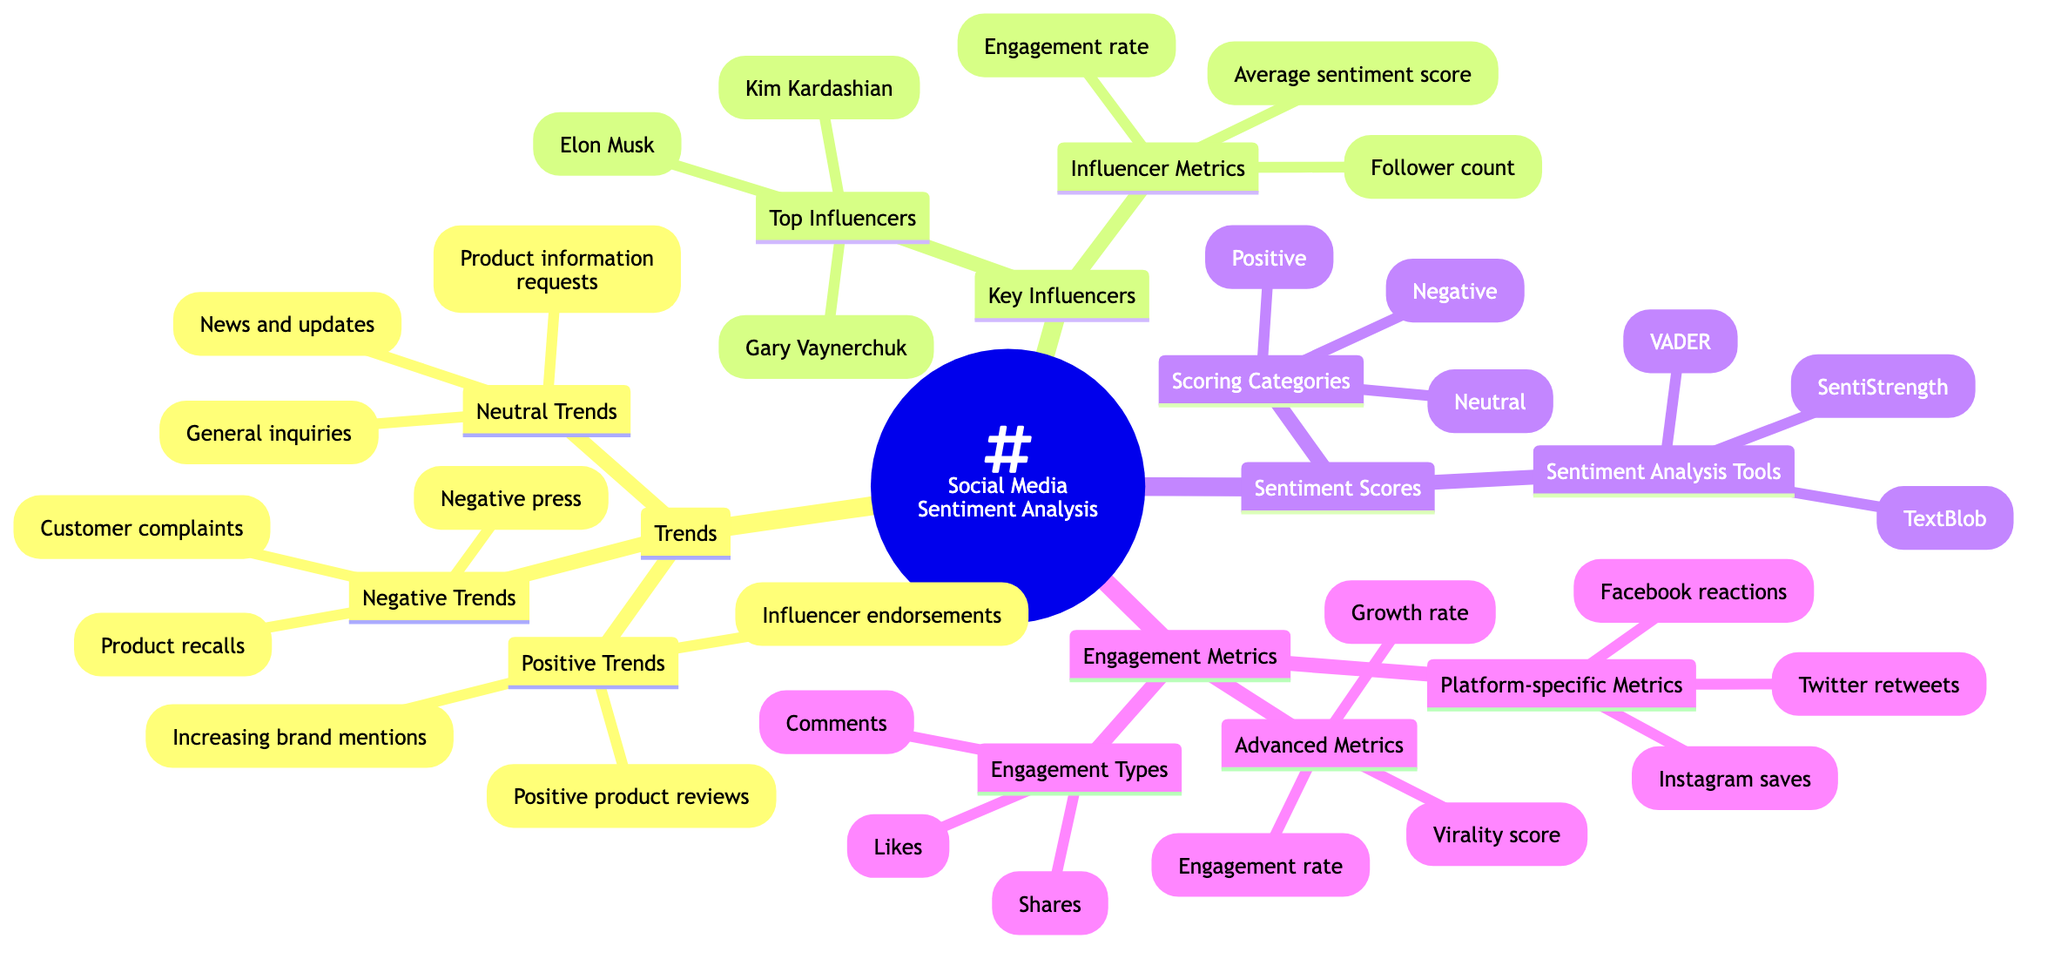What are the three Positive Trends listed? The diagram lists three Positive Trends under the Trends section. They are "Increasing brand mentions," "Positive product reviews," and "Influencer endorsements."
Answer: Increasing brand mentions, Positive product reviews, Influencer endorsements How many Top Influencers are mentioned? The Top Influencers section lists three individuals: "Kim Kardashian," "Gary Vaynerchuk," and "Elon Musk." Therefore, the number of Top Influencers is three.
Answer: 3 What is the first Sentiment Analysis Tool mentioned? The Sentiment Analysis Tools section includes three tools, and "VADER" is the first one listed.
Answer: VADER What Engagement Type has the highest engagement metric category? The Engagement Types section presents three types of engagement: "Likes," "Comments," and "Shares." The question implies understanding that each of these is simply a type and does not state a hierarchy. Thus, no Engagement Type could be determined to have the highest measurement.
Answer: None Which sentiment category is NOT listed? The Sentiment Scores section lists three categories: "Positive," "Neutral," and "Negative." The question looks for categories that are not stated in the diagram. Possible sentiments like "Mixed" or "Ambiguous" are not mentioned.
Answer: Mixed What metrics are used to evaluate influencers? The Influencer Metrics section provides three metrics, which include "Follower count," "Engagement rate," and "Average sentiment score" to assess influencers.
Answer: Follower count, Engagement rate, Average sentiment score Which engagement metric measures interactions on a single platform? The Advanced Metrics section includes metrics like "Engagement rate," "Virality score," and "Growth rate." However, the question requires looking at platform-specific engagement metrics, which include "Twitter retweets," "Instagram saves," and "Facebook reactions." Here, "Twitter retweets" is one metric specifically tied to a platform.
Answer: Twitter retweets What is the total number of categories listed for Sentiment Scores? The Sentiment Scores section contains two categories: "Scoring Categories" and "Sentiment Analysis Tools." Under the Scoring Categories, there are three types: "Positive," "Neutral," and "Negative." Thus, there are a total of two categories listed.
Answer: 2 